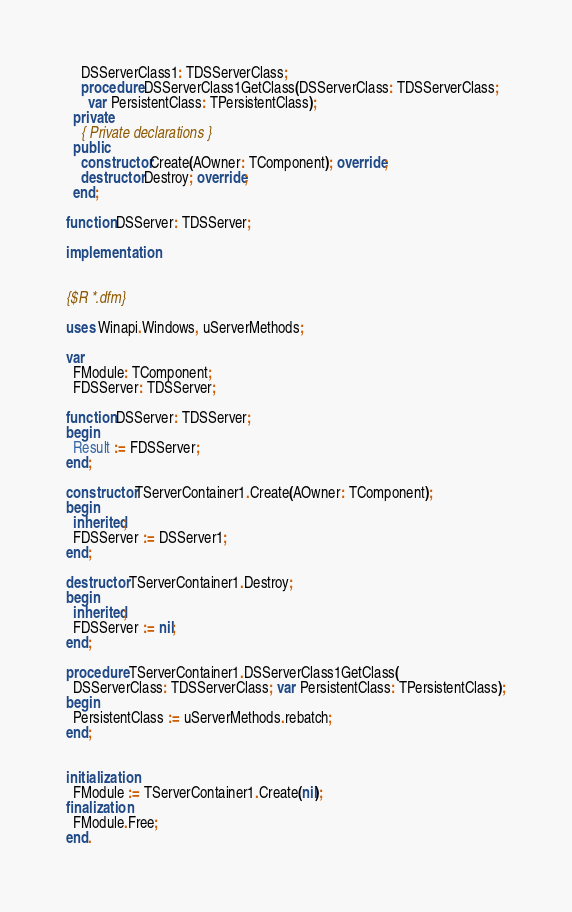Convert code to text. <code><loc_0><loc_0><loc_500><loc_500><_Pascal_>    DSServerClass1: TDSServerClass;
    procedure DSServerClass1GetClass(DSServerClass: TDSServerClass;
      var PersistentClass: TPersistentClass);
  private
    { Private declarations }
  public
    constructor Create(AOwner: TComponent); override;
    destructor Destroy; override;
  end;

function DSServer: TDSServer;

implementation


{$R *.dfm}

uses Winapi.Windows, uServerMethods;

var
  FModule: TComponent;
  FDSServer: TDSServer;

function DSServer: TDSServer;
begin
  Result := FDSServer;
end;

constructor TServerContainer1.Create(AOwner: TComponent);
begin
  inherited;
  FDSServer := DSServer1;
end;

destructor TServerContainer1.Destroy;
begin
  inherited;
  FDSServer := nil;
end;

procedure TServerContainer1.DSServerClass1GetClass(
  DSServerClass: TDSServerClass; var PersistentClass: TPersistentClass);
begin
  PersistentClass := uServerMethods.rebatch;
end;


initialization
  FModule := TServerContainer1.Create(nil);
finalization
  FModule.Free;
end.

</code> 